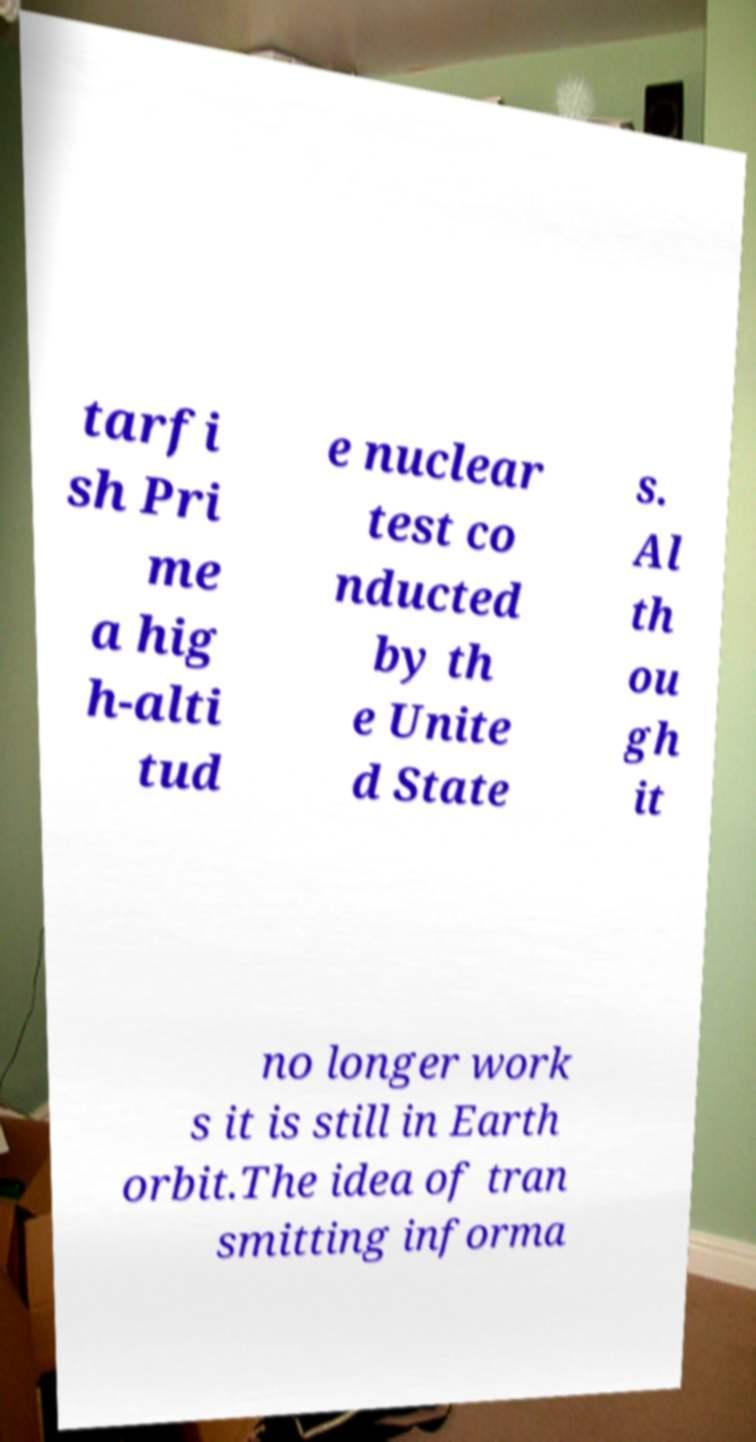Please read and relay the text visible in this image. What does it say? tarfi sh Pri me a hig h-alti tud e nuclear test co nducted by th e Unite d State s. Al th ou gh it no longer work s it is still in Earth orbit.The idea of tran smitting informa 